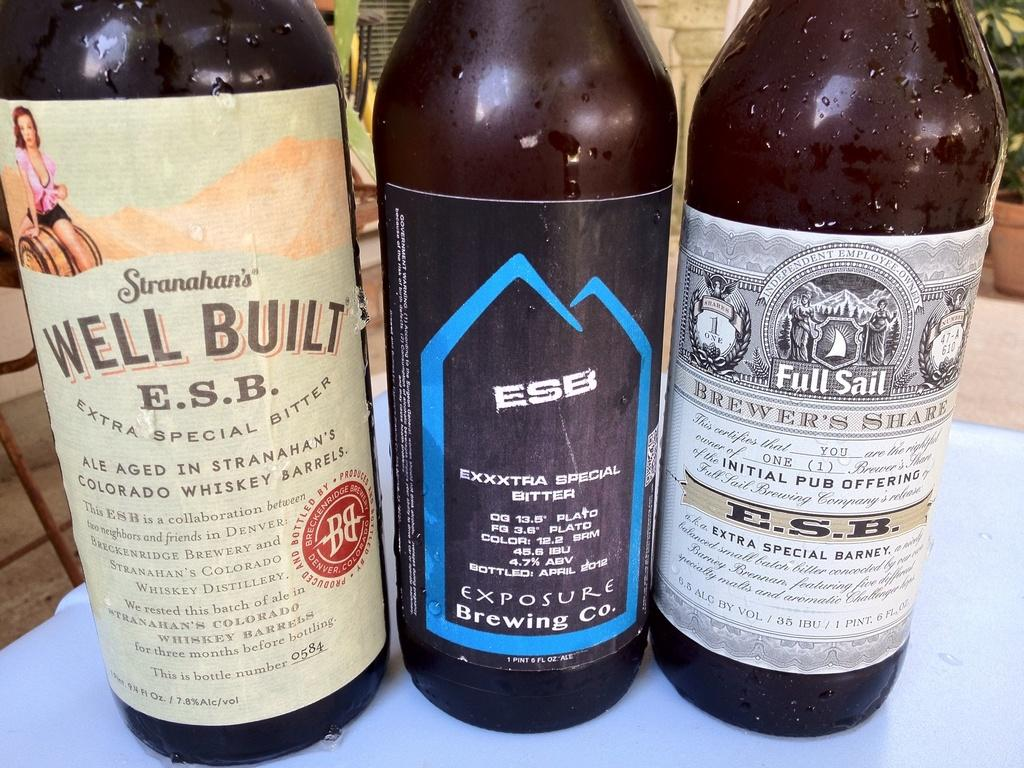Provide a one-sentence caption for the provided image. Well Built brand bitter ale is next to two other bitter ales from different companies. 